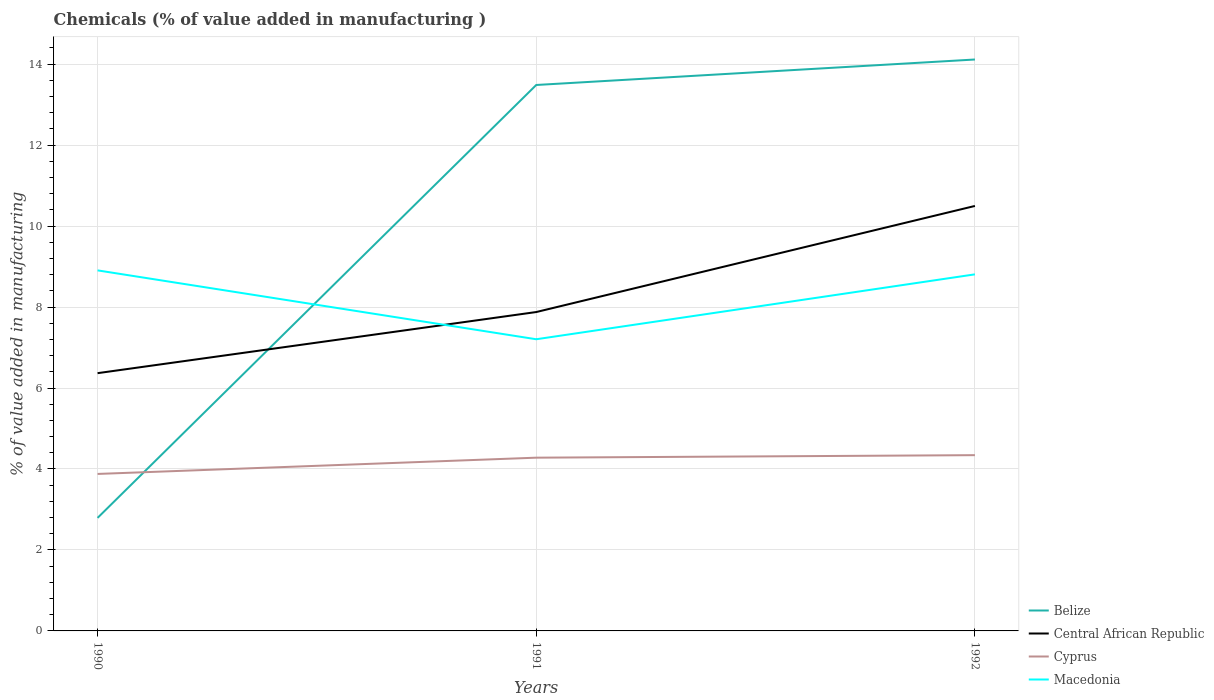Does the line corresponding to Macedonia intersect with the line corresponding to Belize?
Keep it short and to the point. Yes. Across all years, what is the maximum value added in manufacturing chemicals in Central African Republic?
Give a very brief answer. 6.37. In which year was the value added in manufacturing chemicals in Cyprus maximum?
Provide a succinct answer. 1990. What is the total value added in manufacturing chemicals in Belize in the graph?
Give a very brief answer. -0.63. What is the difference between the highest and the second highest value added in manufacturing chemicals in Central African Republic?
Make the answer very short. 4.13. What is the difference between the highest and the lowest value added in manufacturing chemicals in Cyprus?
Give a very brief answer. 2. Is the value added in manufacturing chemicals in Central African Republic strictly greater than the value added in manufacturing chemicals in Belize over the years?
Make the answer very short. No. How many lines are there?
Offer a terse response. 4. Are the values on the major ticks of Y-axis written in scientific E-notation?
Your response must be concise. No. Does the graph contain any zero values?
Your answer should be compact. No. Does the graph contain grids?
Make the answer very short. Yes. Where does the legend appear in the graph?
Provide a succinct answer. Bottom right. What is the title of the graph?
Give a very brief answer. Chemicals (% of value added in manufacturing ). Does "Nigeria" appear as one of the legend labels in the graph?
Offer a terse response. No. What is the label or title of the Y-axis?
Make the answer very short. % of value added in manufacturing. What is the % of value added in manufacturing in Belize in 1990?
Give a very brief answer. 2.79. What is the % of value added in manufacturing of Central African Republic in 1990?
Give a very brief answer. 6.37. What is the % of value added in manufacturing in Cyprus in 1990?
Make the answer very short. 3.88. What is the % of value added in manufacturing of Macedonia in 1990?
Provide a short and direct response. 8.91. What is the % of value added in manufacturing in Belize in 1991?
Provide a short and direct response. 13.49. What is the % of value added in manufacturing in Central African Republic in 1991?
Your answer should be very brief. 7.88. What is the % of value added in manufacturing of Cyprus in 1991?
Keep it short and to the point. 4.28. What is the % of value added in manufacturing in Macedonia in 1991?
Ensure brevity in your answer.  7.2. What is the % of value added in manufacturing of Belize in 1992?
Provide a short and direct response. 14.12. What is the % of value added in manufacturing of Central African Republic in 1992?
Give a very brief answer. 10.5. What is the % of value added in manufacturing of Cyprus in 1992?
Provide a short and direct response. 4.34. What is the % of value added in manufacturing in Macedonia in 1992?
Give a very brief answer. 8.81. Across all years, what is the maximum % of value added in manufacturing of Belize?
Provide a succinct answer. 14.12. Across all years, what is the maximum % of value added in manufacturing in Central African Republic?
Provide a short and direct response. 10.5. Across all years, what is the maximum % of value added in manufacturing in Cyprus?
Your response must be concise. 4.34. Across all years, what is the maximum % of value added in manufacturing in Macedonia?
Provide a short and direct response. 8.91. Across all years, what is the minimum % of value added in manufacturing in Belize?
Offer a terse response. 2.79. Across all years, what is the minimum % of value added in manufacturing in Central African Republic?
Offer a very short reply. 6.37. Across all years, what is the minimum % of value added in manufacturing of Cyprus?
Keep it short and to the point. 3.88. Across all years, what is the minimum % of value added in manufacturing of Macedonia?
Provide a short and direct response. 7.2. What is the total % of value added in manufacturing in Belize in the graph?
Your response must be concise. 30.39. What is the total % of value added in manufacturing of Central African Republic in the graph?
Your answer should be compact. 24.74. What is the total % of value added in manufacturing in Cyprus in the graph?
Provide a succinct answer. 12.5. What is the total % of value added in manufacturing of Macedonia in the graph?
Offer a terse response. 24.92. What is the difference between the % of value added in manufacturing in Belize in 1990 and that in 1991?
Your answer should be very brief. -10.69. What is the difference between the % of value added in manufacturing of Central African Republic in 1990 and that in 1991?
Provide a succinct answer. -1.51. What is the difference between the % of value added in manufacturing of Cyprus in 1990 and that in 1991?
Provide a succinct answer. -0.4. What is the difference between the % of value added in manufacturing in Macedonia in 1990 and that in 1991?
Provide a short and direct response. 1.7. What is the difference between the % of value added in manufacturing in Belize in 1990 and that in 1992?
Ensure brevity in your answer.  -11.32. What is the difference between the % of value added in manufacturing of Central African Republic in 1990 and that in 1992?
Offer a very short reply. -4.13. What is the difference between the % of value added in manufacturing of Cyprus in 1990 and that in 1992?
Your answer should be compact. -0.46. What is the difference between the % of value added in manufacturing in Macedonia in 1990 and that in 1992?
Offer a very short reply. 0.1. What is the difference between the % of value added in manufacturing in Belize in 1991 and that in 1992?
Make the answer very short. -0.63. What is the difference between the % of value added in manufacturing in Central African Republic in 1991 and that in 1992?
Keep it short and to the point. -2.62. What is the difference between the % of value added in manufacturing of Cyprus in 1991 and that in 1992?
Offer a terse response. -0.06. What is the difference between the % of value added in manufacturing of Macedonia in 1991 and that in 1992?
Provide a succinct answer. -1.6. What is the difference between the % of value added in manufacturing in Belize in 1990 and the % of value added in manufacturing in Central African Republic in 1991?
Offer a very short reply. -5.08. What is the difference between the % of value added in manufacturing of Belize in 1990 and the % of value added in manufacturing of Cyprus in 1991?
Your answer should be very brief. -1.49. What is the difference between the % of value added in manufacturing in Belize in 1990 and the % of value added in manufacturing in Macedonia in 1991?
Your answer should be compact. -4.41. What is the difference between the % of value added in manufacturing in Central African Republic in 1990 and the % of value added in manufacturing in Cyprus in 1991?
Make the answer very short. 2.09. What is the difference between the % of value added in manufacturing in Central African Republic in 1990 and the % of value added in manufacturing in Macedonia in 1991?
Keep it short and to the point. -0.84. What is the difference between the % of value added in manufacturing in Cyprus in 1990 and the % of value added in manufacturing in Macedonia in 1991?
Give a very brief answer. -3.33. What is the difference between the % of value added in manufacturing in Belize in 1990 and the % of value added in manufacturing in Central African Republic in 1992?
Give a very brief answer. -7.71. What is the difference between the % of value added in manufacturing in Belize in 1990 and the % of value added in manufacturing in Cyprus in 1992?
Offer a very short reply. -1.55. What is the difference between the % of value added in manufacturing of Belize in 1990 and the % of value added in manufacturing of Macedonia in 1992?
Provide a succinct answer. -6.02. What is the difference between the % of value added in manufacturing of Central African Republic in 1990 and the % of value added in manufacturing of Cyprus in 1992?
Give a very brief answer. 2.03. What is the difference between the % of value added in manufacturing of Central African Republic in 1990 and the % of value added in manufacturing of Macedonia in 1992?
Your answer should be very brief. -2.44. What is the difference between the % of value added in manufacturing of Cyprus in 1990 and the % of value added in manufacturing of Macedonia in 1992?
Keep it short and to the point. -4.93. What is the difference between the % of value added in manufacturing of Belize in 1991 and the % of value added in manufacturing of Central African Republic in 1992?
Offer a very short reply. 2.99. What is the difference between the % of value added in manufacturing in Belize in 1991 and the % of value added in manufacturing in Cyprus in 1992?
Your answer should be very brief. 9.14. What is the difference between the % of value added in manufacturing in Belize in 1991 and the % of value added in manufacturing in Macedonia in 1992?
Your response must be concise. 4.68. What is the difference between the % of value added in manufacturing of Central African Republic in 1991 and the % of value added in manufacturing of Cyprus in 1992?
Ensure brevity in your answer.  3.54. What is the difference between the % of value added in manufacturing of Central African Republic in 1991 and the % of value added in manufacturing of Macedonia in 1992?
Make the answer very short. -0.93. What is the difference between the % of value added in manufacturing in Cyprus in 1991 and the % of value added in manufacturing in Macedonia in 1992?
Offer a very short reply. -4.53. What is the average % of value added in manufacturing of Belize per year?
Your answer should be very brief. 10.13. What is the average % of value added in manufacturing in Central African Republic per year?
Offer a very short reply. 8.25. What is the average % of value added in manufacturing in Cyprus per year?
Give a very brief answer. 4.17. What is the average % of value added in manufacturing of Macedonia per year?
Your answer should be very brief. 8.31. In the year 1990, what is the difference between the % of value added in manufacturing of Belize and % of value added in manufacturing of Central African Republic?
Give a very brief answer. -3.57. In the year 1990, what is the difference between the % of value added in manufacturing in Belize and % of value added in manufacturing in Cyprus?
Ensure brevity in your answer.  -1.09. In the year 1990, what is the difference between the % of value added in manufacturing in Belize and % of value added in manufacturing in Macedonia?
Provide a short and direct response. -6.11. In the year 1990, what is the difference between the % of value added in manufacturing in Central African Republic and % of value added in manufacturing in Cyprus?
Your response must be concise. 2.49. In the year 1990, what is the difference between the % of value added in manufacturing of Central African Republic and % of value added in manufacturing of Macedonia?
Provide a succinct answer. -2.54. In the year 1990, what is the difference between the % of value added in manufacturing of Cyprus and % of value added in manufacturing of Macedonia?
Your response must be concise. -5.03. In the year 1991, what is the difference between the % of value added in manufacturing in Belize and % of value added in manufacturing in Central African Republic?
Provide a succinct answer. 5.61. In the year 1991, what is the difference between the % of value added in manufacturing in Belize and % of value added in manufacturing in Cyprus?
Keep it short and to the point. 9.21. In the year 1991, what is the difference between the % of value added in manufacturing in Belize and % of value added in manufacturing in Macedonia?
Ensure brevity in your answer.  6.28. In the year 1991, what is the difference between the % of value added in manufacturing in Central African Republic and % of value added in manufacturing in Cyprus?
Offer a very short reply. 3.6. In the year 1991, what is the difference between the % of value added in manufacturing of Central African Republic and % of value added in manufacturing of Macedonia?
Offer a very short reply. 0.67. In the year 1991, what is the difference between the % of value added in manufacturing in Cyprus and % of value added in manufacturing in Macedonia?
Make the answer very short. -2.93. In the year 1992, what is the difference between the % of value added in manufacturing of Belize and % of value added in manufacturing of Central African Republic?
Your answer should be very brief. 3.62. In the year 1992, what is the difference between the % of value added in manufacturing of Belize and % of value added in manufacturing of Cyprus?
Make the answer very short. 9.77. In the year 1992, what is the difference between the % of value added in manufacturing in Belize and % of value added in manufacturing in Macedonia?
Make the answer very short. 5.31. In the year 1992, what is the difference between the % of value added in manufacturing in Central African Republic and % of value added in manufacturing in Cyprus?
Provide a short and direct response. 6.16. In the year 1992, what is the difference between the % of value added in manufacturing of Central African Republic and % of value added in manufacturing of Macedonia?
Keep it short and to the point. 1.69. In the year 1992, what is the difference between the % of value added in manufacturing in Cyprus and % of value added in manufacturing in Macedonia?
Your response must be concise. -4.47. What is the ratio of the % of value added in manufacturing of Belize in 1990 to that in 1991?
Ensure brevity in your answer.  0.21. What is the ratio of the % of value added in manufacturing in Central African Republic in 1990 to that in 1991?
Offer a terse response. 0.81. What is the ratio of the % of value added in manufacturing of Cyprus in 1990 to that in 1991?
Keep it short and to the point. 0.91. What is the ratio of the % of value added in manufacturing of Macedonia in 1990 to that in 1991?
Keep it short and to the point. 1.24. What is the ratio of the % of value added in manufacturing in Belize in 1990 to that in 1992?
Provide a succinct answer. 0.2. What is the ratio of the % of value added in manufacturing of Central African Republic in 1990 to that in 1992?
Your answer should be compact. 0.61. What is the ratio of the % of value added in manufacturing in Cyprus in 1990 to that in 1992?
Your response must be concise. 0.89. What is the ratio of the % of value added in manufacturing in Macedonia in 1990 to that in 1992?
Your response must be concise. 1.01. What is the ratio of the % of value added in manufacturing of Belize in 1991 to that in 1992?
Your response must be concise. 0.96. What is the ratio of the % of value added in manufacturing of Central African Republic in 1991 to that in 1992?
Your answer should be compact. 0.75. What is the ratio of the % of value added in manufacturing of Cyprus in 1991 to that in 1992?
Make the answer very short. 0.99. What is the ratio of the % of value added in manufacturing of Macedonia in 1991 to that in 1992?
Give a very brief answer. 0.82. What is the difference between the highest and the second highest % of value added in manufacturing of Belize?
Offer a terse response. 0.63. What is the difference between the highest and the second highest % of value added in manufacturing of Central African Republic?
Provide a short and direct response. 2.62. What is the difference between the highest and the second highest % of value added in manufacturing in Cyprus?
Ensure brevity in your answer.  0.06. What is the difference between the highest and the second highest % of value added in manufacturing of Macedonia?
Keep it short and to the point. 0.1. What is the difference between the highest and the lowest % of value added in manufacturing in Belize?
Your response must be concise. 11.32. What is the difference between the highest and the lowest % of value added in manufacturing in Central African Republic?
Your response must be concise. 4.13. What is the difference between the highest and the lowest % of value added in manufacturing of Cyprus?
Your response must be concise. 0.46. What is the difference between the highest and the lowest % of value added in manufacturing of Macedonia?
Give a very brief answer. 1.7. 